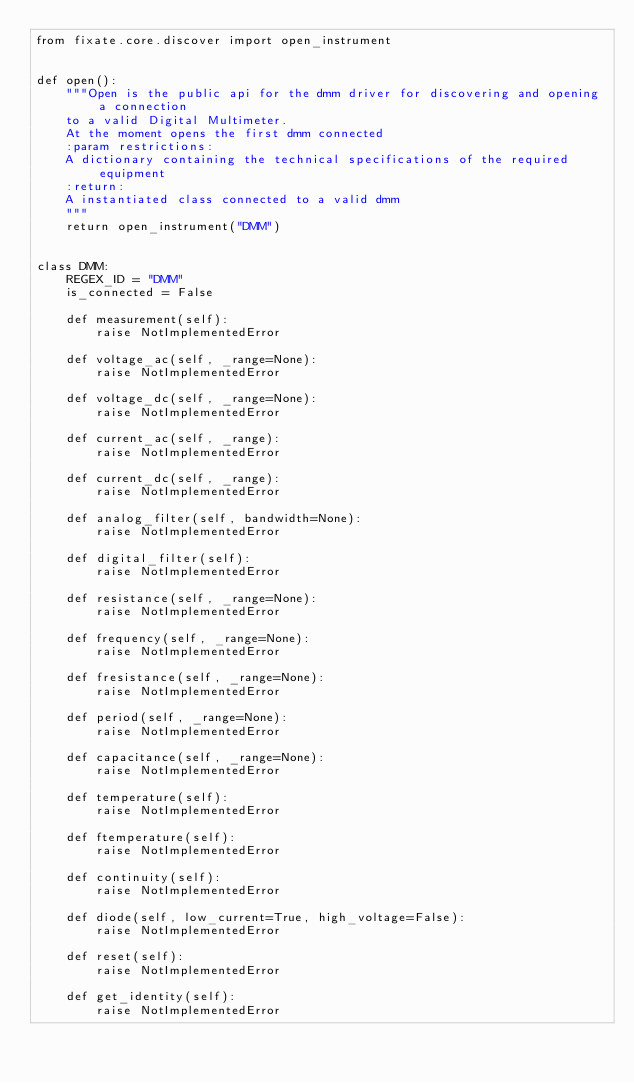<code> <loc_0><loc_0><loc_500><loc_500><_Python_>from fixate.core.discover import open_instrument


def open():
    """Open is the public api for the dmm driver for discovering and opening a connection
    to a valid Digital Multimeter.
    At the moment opens the first dmm connected
    :param restrictions:
    A dictionary containing the technical specifications of the required equipment
    :return:
    A instantiated class connected to a valid dmm
    """
    return open_instrument("DMM")


class DMM:
    REGEX_ID = "DMM"
    is_connected = False

    def measurement(self):
        raise NotImplementedError

    def voltage_ac(self, _range=None):
        raise NotImplementedError

    def voltage_dc(self, _range=None):
        raise NotImplementedError

    def current_ac(self, _range):
        raise NotImplementedError

    def current_dc(self, _range):
        raise NotImplementedError

    def analog_filter(self, bandwidth=None):
        raise NotImplementedError

    def digital_filter(self):
        raise NotImplementedError

    def resistance(self, _range=None):
        raise NotImplementedError

    def frequency(self, _range=None):
        raise NotImplementedError

    def fresistance(self, _range=None):
        raise NotImplementedError

    def period(self, _range=None):
        raise NotImplementedError

    def capacitance(self, _range=None):
        raise NotImplementedError

    def temperature(self):
        raise NotImplementedError

    def ftemperature(self):
        raise NotImplementedError

    def continuity(self):
        raise NotImplementedError

    def diode(self, low_current=True, high_voltage=False):
        raise NotImplementedError

    def reset(self):
        raise NotImplementedError

    def get_identity(self):
        raise NotImplementedError
</code> 